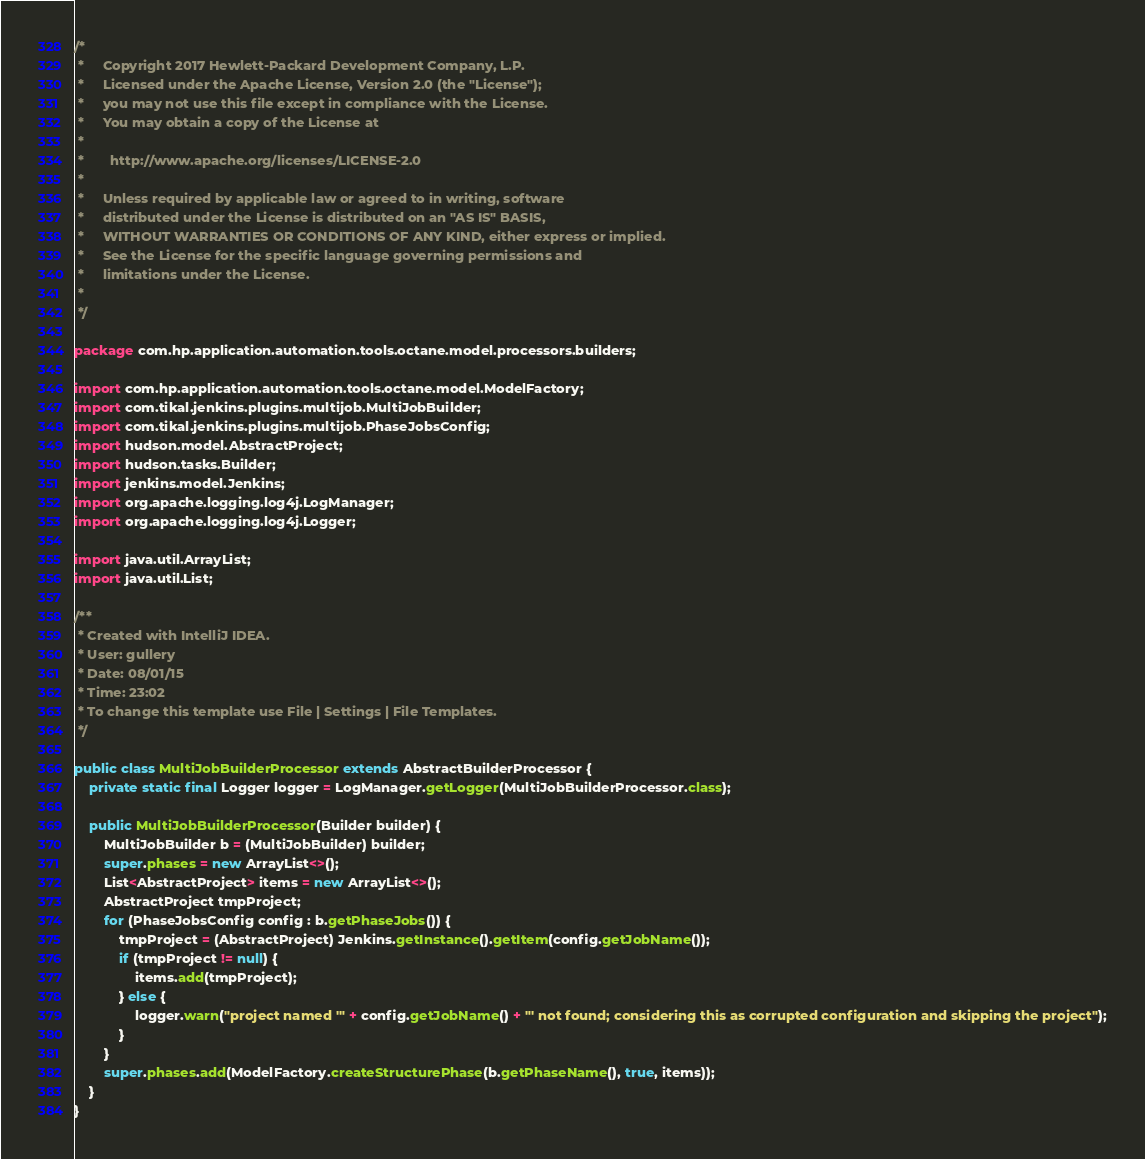Convert code to text. <code><loc_0><loc_0><loc_500><loc_500><_Java_>/*
 *     Copyright 2017 Hewlett-Packard Development Company, L.P.
 *     Licensed under the Apache License, Version 2.0 (the "License");
 *     you may not use this file except in compliance with the License.
 *     You may obtain a copy of the License at
 *
 *       http://www.apache.org/licenses/LICENSE-2.0
 *
 *     Unless required by applicable law or agreed to in writing, software
 *     distributed under the License is distributed on an "AS IS" BASIS,
 *     WITHOUT WARRANTIES OR CONDITIONS OF ANY KIND, either express or implied.
 *     See the License for the specific language governing permissions and
 *     limitations under the License.
 *
 */

package com.hp.application.automation.tools.octane.model.processors.builders;

import com.hp.application.automation.tools.octane.model.ModelFactory;
import com.tikal.jenkins.plugins.multijob.MultiJobBuilder;
import com.tikal.jenkins.plugins.multijob.PhaseJobsConfig;
import hudson.model.AbstractProject;
import hudson.tasks.Builder;
import jenkins.model.Jenkins;
import org.apache.logging.log4j.LogManager;
import org.apache.logging.log4j.Logger;

import java.util.ArrayList;
import java.util.List;

/**
 * Created with IntelliJ IDEA.
 * User: gullery
 * Date: 08/01/15
 * Time: 23:02
 * To change this template use File | Settings | File Templates.
 */

public class MultiJobBuilderProcessor extends AbstractBuilderProcessor {
	private static final Logger logger = LogManager.getLogger(MultiJobBuilderProcessor.class);

	public MultiJobBuilderProcessor(Builder builder) {
		MultiJobBuilder b = (MultiJobBuilder) builder;
		super.phases = new ArrayList<>();
		List<AbstractProject> items = new ArrayList<>();
		AbstractProject tmpProject;
		for (PhaseJobsConfig config : b.getPhaseJobs()) {
			tmpProject = (AbstractProject) Jenkins.getInstance().getItem(config.getJobName());
			if (tmpProject != null) {
				items.add(tmpProject);
			} else {
				logger.warn("project named '" + config.getJobName() + "' not found; considering this as corrupted configuration and skipping the project");
			}
		}
		super.phases.add(ModelFactory.createStructurePhase(b.getPhaseName(), true, items));
	}
}
</code> 